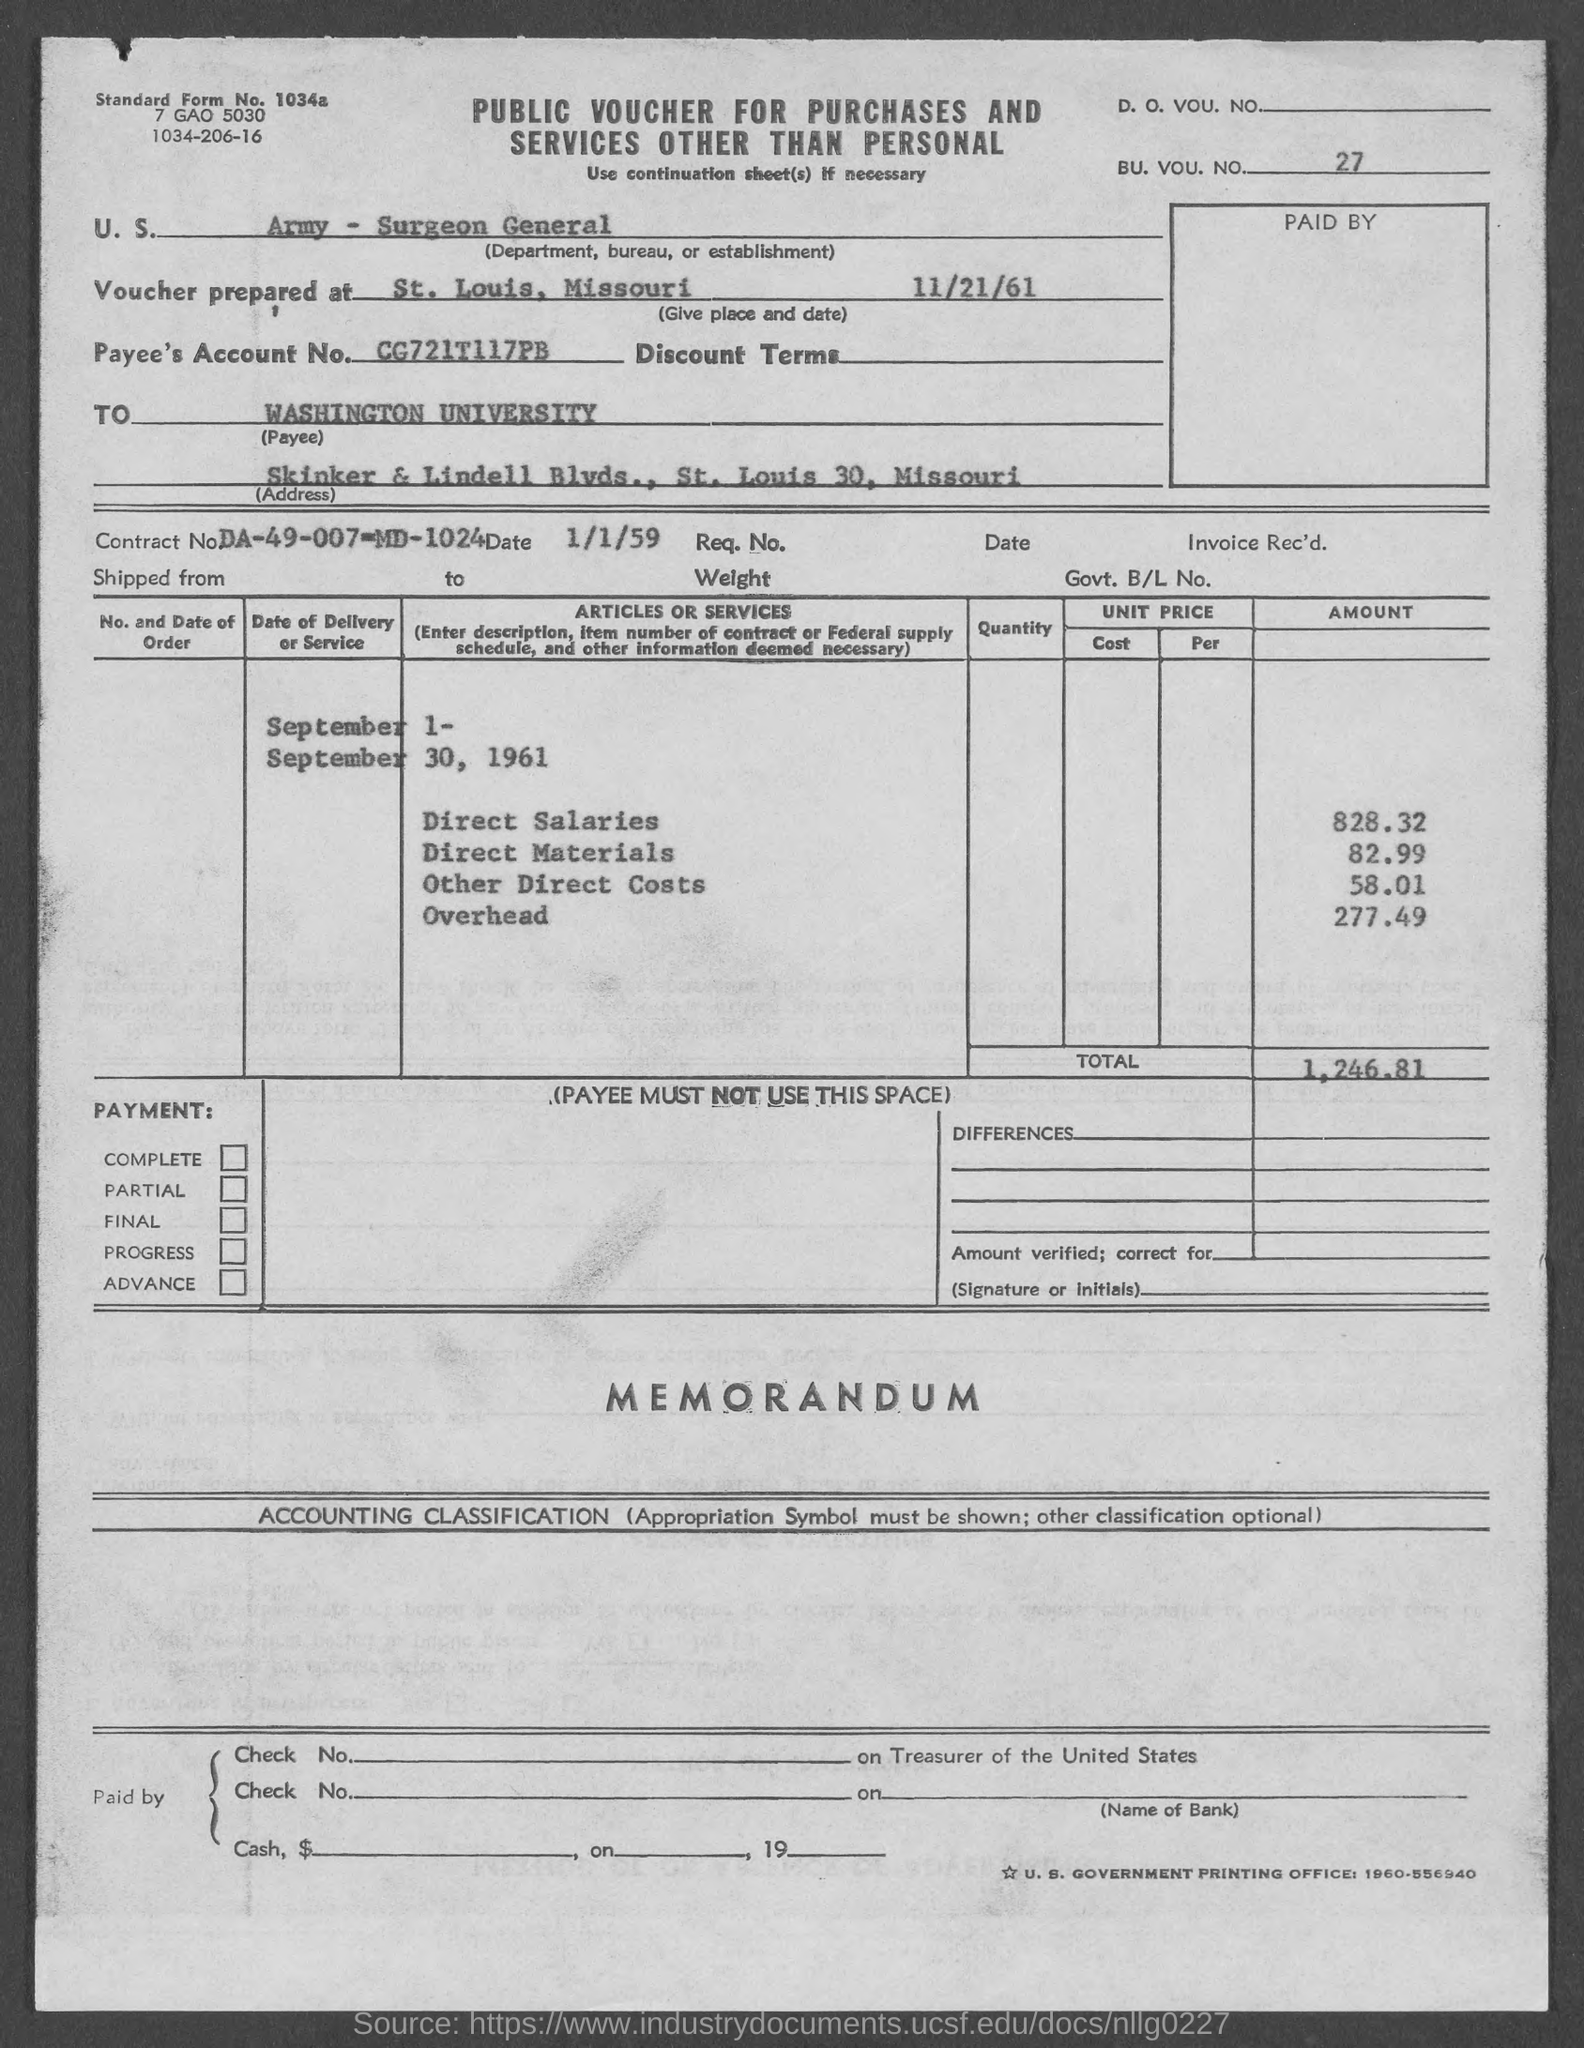Can you tell me the total amount for Other Direct Costs on this document? The total amount for Other Direct Costs, as listed, is $58.01. 